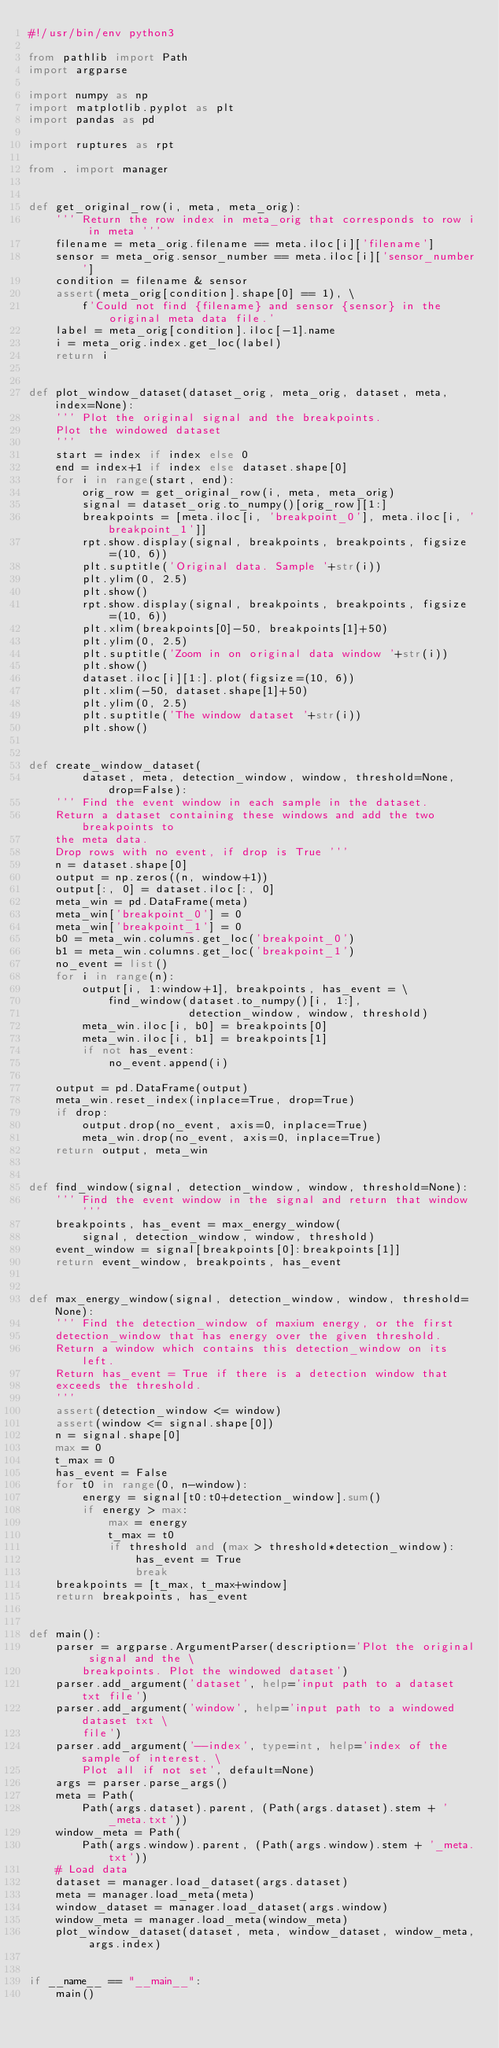<code> <loc_0><loc_0><loc_500><loc_500><_Python_>#!/usr/bin/env python3

from pathlib import Path
import argparse

import numpy as np
import matplotlib.pyplot as plt
import pandas as pd

import ruptures as rpt

from . import manager


def get_original_row(i, meta, meta_orig):
    ''' Return the row index in meta_orig that corresponds to row i in meta '''
    filename = meta_orig.filename == meta.iloc[i]['filename'] 
    sensor = meta_orig.sensor_number == meta.iloc[i]['sensor_number']
    condition = filename & sensor
    assert(meta_orig[condition].shape[0] == 1), \
        f'Could not find {filename} and sensor {sensor} in the original meta data file.'
    label = meta_orig[condition].iloc[-1].name
    i = meta_orig.index.get_loc(label)
    return i


def plot_window_dataset(dataset_orig, meta_orig, dataset, meta, index=None):
    ''' Plot the original signal and the breakpoints.
    Plot the windowed dataset
    '''
    start = index if index else 0
    end = index+1 if index else dataset.shape[0]
    for i in range(start, end):
        orig_row = get_original_row(i, meta, meta_orig)
        signal = dataset_orig.to_numpy()[orig_row][1:]
        breakpoints = [meta.iloc[i, 'breakpoint_0'], meta.iloc[i, 'breakpoint_1']]
        rpt.show.display(signal, breakpoints, breakpoints, figsize=(10, 6))
        plt.suptitle('Original data. Sample '+str(i))
        plt.ylim(0, 2.5)
        plt.show()
        rpt.show.display(signal, breakpoints, breakpoints, figsize=(10, 6))
        plt.xlim(breakpoints[0]-50, breakpoints[1]+50)
        plt.ylim(0, 2.5)
        plt.suptitle('Zoom in on original data window '+str(i))
        plt.show()
        dataset.iloc[i][1:].plot(figsize=(10, 6))
        plt.xlim(-50, dataset.shape[1]+50)
        plt.ylim(0, 2.5)
        plt.suptitle('The window dataset '+str(i))
        plt.show()


def create_window_dataset(
        dataset, meta, detection_window, window, threshold=None, drop=False):
    ''' Find the event window in each sample in the dataset.
    Return a dataset containing these windows and add the two breakpoints to
    the meta data.
    Drop rows with no event, if drop is True '''
    n = dataset.shape[0]
    output = np.zeros((n, window+1))
    output[:, 0] = dataset.iloc[:, 0]
    meta_win = pd.DataFrame(meta)
    meta_win['breakpoint_0'] = 0
    meta_win['breakpoint_1'] = 0
    b0 = meta_win.columns.get_loc('breakpoint_0')
    b1 = meta_win.columns.get_loc('breakpoint_1')
    no_event = list()
    for i in range(n):
        output[i, 1:window+1], breakpoints, has_event = \
            find_window(dataset.to_numpy()[i, 1:], 
                        detection_window, window, threshold)
        meta_win.iloc[i, b0] = breakpoints[0]
        meta_win.iloc[i, b1] = breakpoints[1]
        if not has_event:
            no_event.append(i)

    output = pd.DataFrame(output)
    meta_win.reset_index(inplace=True, drop=True)
    if drop:
        output.drop(no_event, axis=0, inplace=True)
        meta_win.drop(no_event, axis=0, inplace=True)
    return output, meta_win


def find_window(signal, detection_window, window, threshold=None):
    ''' Find the event window in the signal and return that window '''
    breakpoints, has_event = max_energy_window(
        signal, detection_window, window, threshold)
    event_window = signal[breakpoints[0]:breakpoints[1]] 
    return event_window, breakpoints, has_event


def max_energy_window(signal, detection_window, window, threshold=None):
    ''' Find the detection_window of maxium energy, or the first
    detection_window that has energy over the given threshold.
    Return a window which contains this detection_window on its left.
    Return has_event = True if there is a detection window that
    exceeds the threshold.
    '''
    assert(detection_window <= window)
    assert(window <= signal.shape[0])
    n = signal.shape[0]
    max = 0
    t_max = 0
    has_event = False
    for t0 in range(0, n-window):
        energy = signal[t0:t0+detection_window].sum()
        if energy > max:
            max = energy
            t_max = t0
            if threshold and (max > threshold*detection_window):
                has_event = True
                break
    breakpoints = [t_max, t_max+window]
    return breakpoints, has_event


def main():
    parser = argparse.ArgumentParser(description='Plot the original signal and the \
        breakpoints. Plot the windowed dataset')
    parser.add_argument('dataset', help='input path to a dataset txt file')
    parser.add_argument('window', help='input path to a windowed dataset txt \
        file')
    parser.add_argument('--index', type=int, help='index of the sample of interest. \
        Plot all if not set', default=None)
    args = parser.parse_args()
    meta = Path(
        Path(args.dataset).parent, (Path(args.dataset).stem + '_meta.txt'))
    window_meta = Path(
        Path(args.window).parent, (Path(args.window).stem + '_meta.txt'))
    # Load data
    dataset = manager.load_dataset(args.dataset)
    meta = manager.load_meta(meta)
    window_dataset = manager.load_dataset(args.window)
    window_meta = manager.load_meta(window_meta)
    plot_window_dataset(dataset, meta, window_dataset, window_meta, args.index)


if __name__ == "__main__":
    main()
</code> 